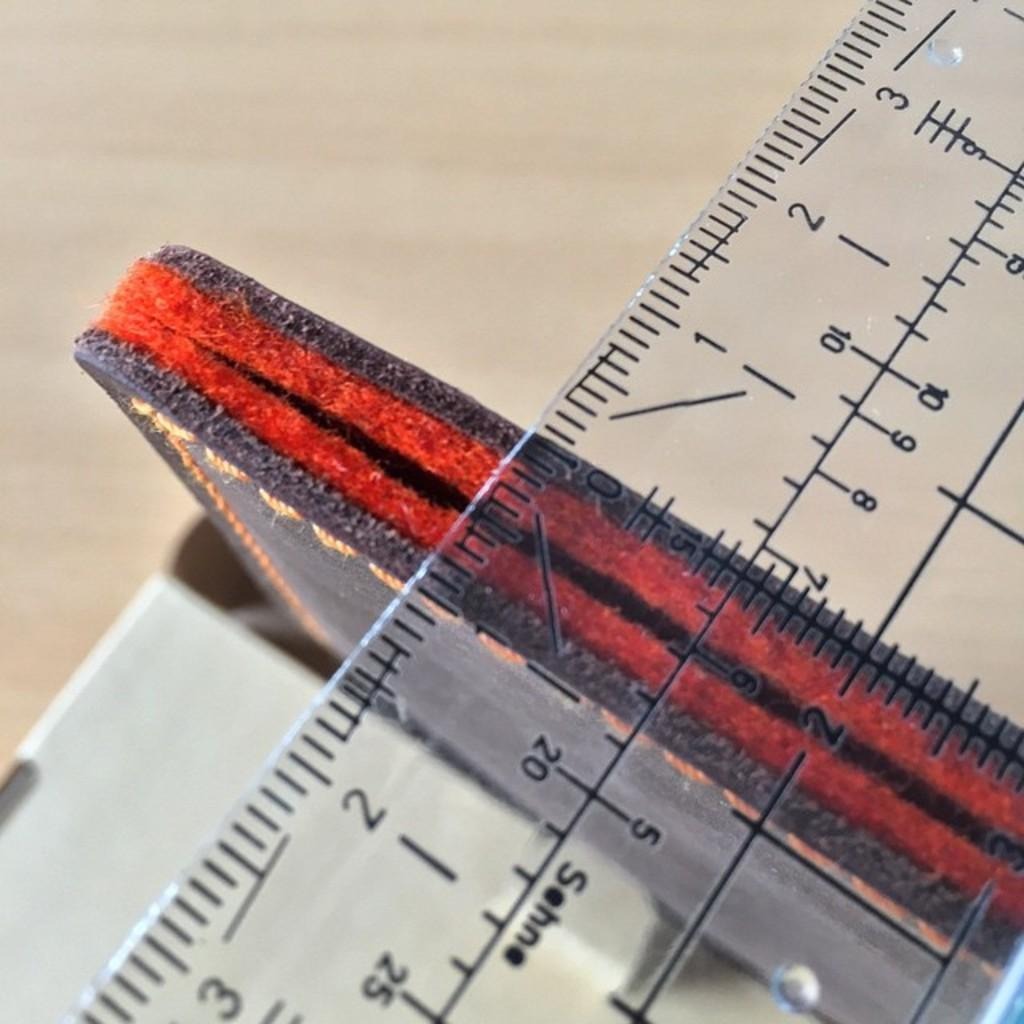What is the main object in the image? There is a scale in the image. What is placed on the scale? There are objects on a platform in the image. What type of activity is the carpenter performing in the image? There is no carpenter present in the image, and therefore no such activity can be observed. 